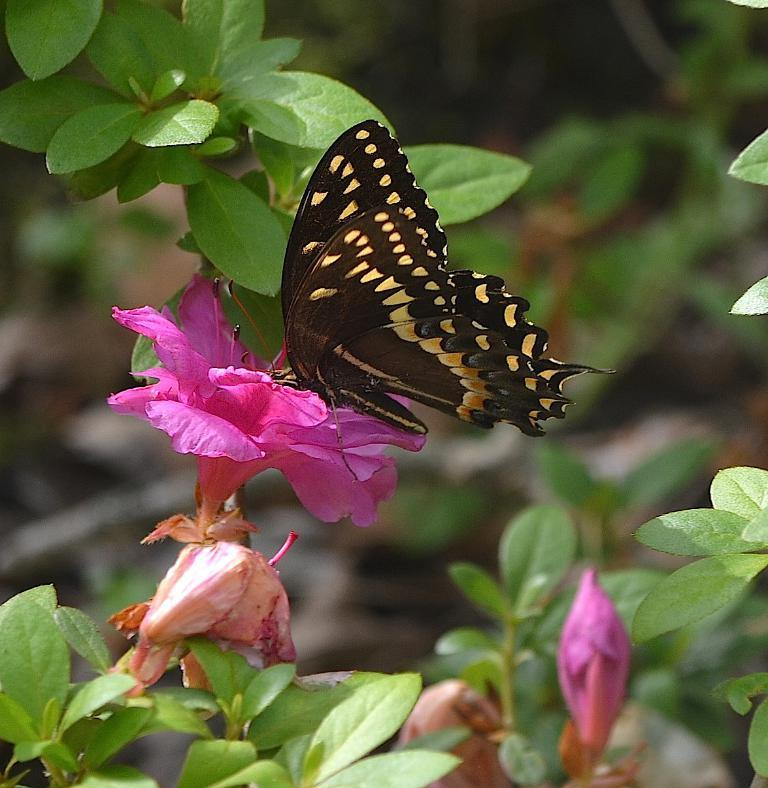What is the main subject of the image? There is a butterfly on a flower in the image. What else can be seen in the image besides the butterfly? There are plants in the image. Can you describe the background of the image? The background of the image is blurry. What type of hair can be seen on the crib in the image? There is no crib present in the image, and therefore no hair can be seen on it. 